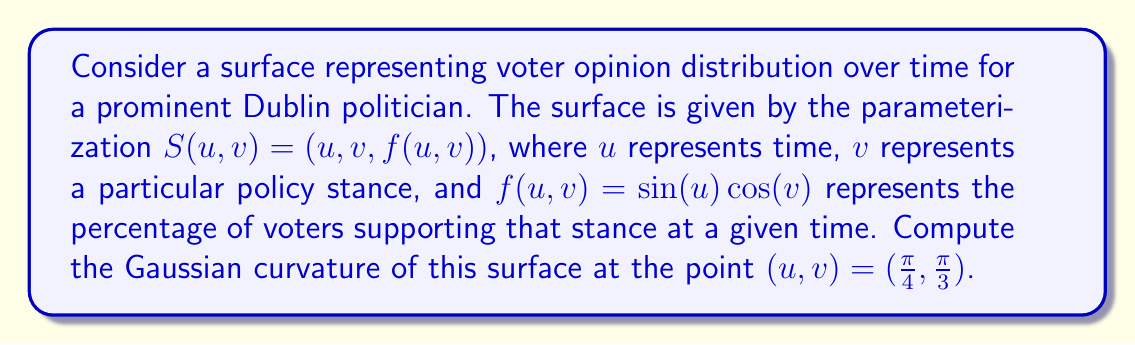Can you answer this question? To compute the Gaussian curvature, we'll follow these steps:

1) First, we need to calculate the partial derivatives:
   $S_u = (1, 0, \cos(u)\cos(v))$
   $S_v = (0, 1, -\sin(u)\sin(v))$

2) Next, we calculate the second partial derivatives:
   $S_{uu} = (0, 0, -\sin(u)\cos(v))$
   $S_{uv} = (0, 0, -\cos(u)\sin(v))$
   $S_{vv} = (0, 0, -\sin(u)\cos(v))$

3) Now we compute the coefficients of the first fundamental form:
   $E = S_u \cdot S_u = 1 + \cos^2(u)\cos^2(v)$
   $F = S_u \cdot S_v = -\cos^2(u)\cos(v)\sin(v)$
   $G = S_v \cdot S_v = 1 + \sin^2(u)\sin^2(v)$

4) We also need the normal vector:
   $N = \frac{S_u \times S_v}{|S_u \times S_v|} = \frac{(-\cos(u)\cos(v), \sin(u)\sin(v), 1)}{\sqrt{1 + \cos^2(u)\cos^2(v) + \sin^2(u)\sin^2(v)}}$

5) Now we can compute the coefficients of the second fundamental form:
   $e = S_{uu} \cdot N = \frac{-\sin(u)\cos(v)}{\sqrt{1 + \cos^2(u)\cos^2(v) + \sin^2(u)\sin^2(v)}}$
   $f = S_{uv} \cdot N = \frac{-\cos(u)\sin(v)}{\sqrt{1 + \cos^2(u)\cos^2(v) + \sin^2(u)\sin^2(v)}}$
   $g = S_{vv} \cdot N = \frac{-\sin(u)\cos(v)}{\sqrt{1 + \cos^2(u)\cos^2(v) + \sin^2(u)\sin^2(v)}}$

6) The Gaussian curvature is given by:
   $K = \frac{eg - f^2}{EG - F^2}$

7) Substituting $u = \frac{\pi}{4}$ and $v = \frac{\pi}{3}$, we get:
   $E = 1 + \frac{1}{4}$, $F = -\frac{\sqrt{3}}{8}$, $G = 1 + \frac{3}{4}$
   $e = g = -\frac{\sqrt{3}}{2\sqrt{7}}$, $f = -\frac{1}{2\sqrt{7}}$

8) Finally, we can compute K:
   $K = \frac{(\frac{\sqrt{3}}{2\sqrt{7}})^2 - (\frac{1}{2\sqrt{7}})^2}{(1 + \frac{1}{4})(1 + \frac{3}{4}) - (\frac{\sqrt{3}}{8})^2} = \frac{1}{7}$
Answer: $K = \frac{1}{7}$ 